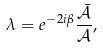Convert formula to latex. <formula><loc_0><loc_0><loc_500><loc_500>\lambda = e ^ { - 2 i \beta } \frac { \bar { \mathcal { A } } } { \mathcal { A } } ,</formula> 